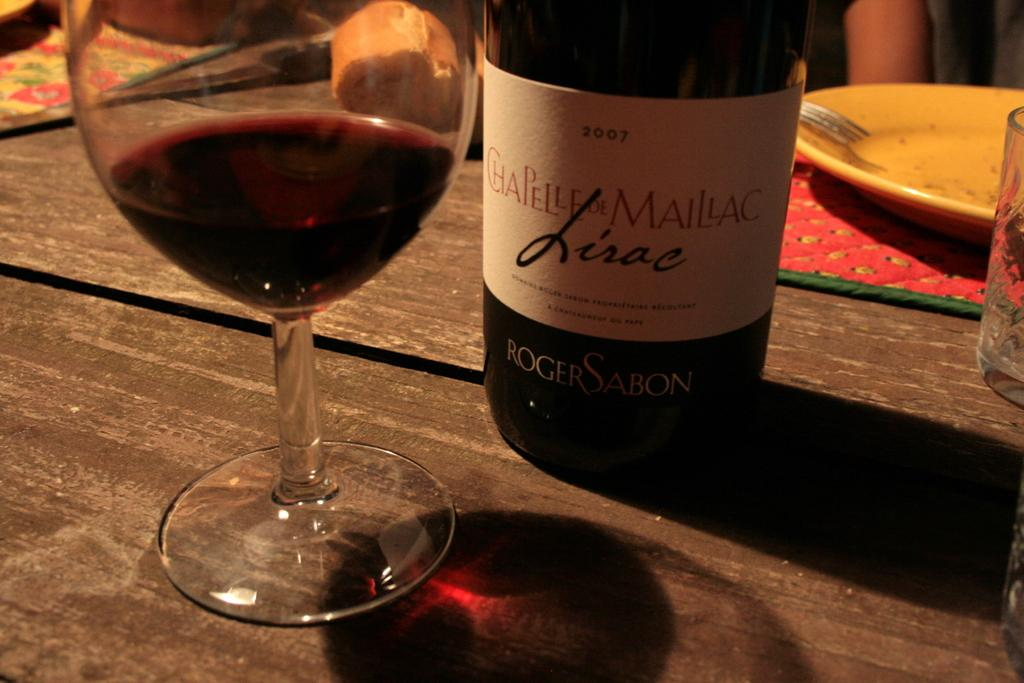<image>
Provide a brief description of the given image. A bottle of Chapelle De Maillac sits next to glass of red wine. 